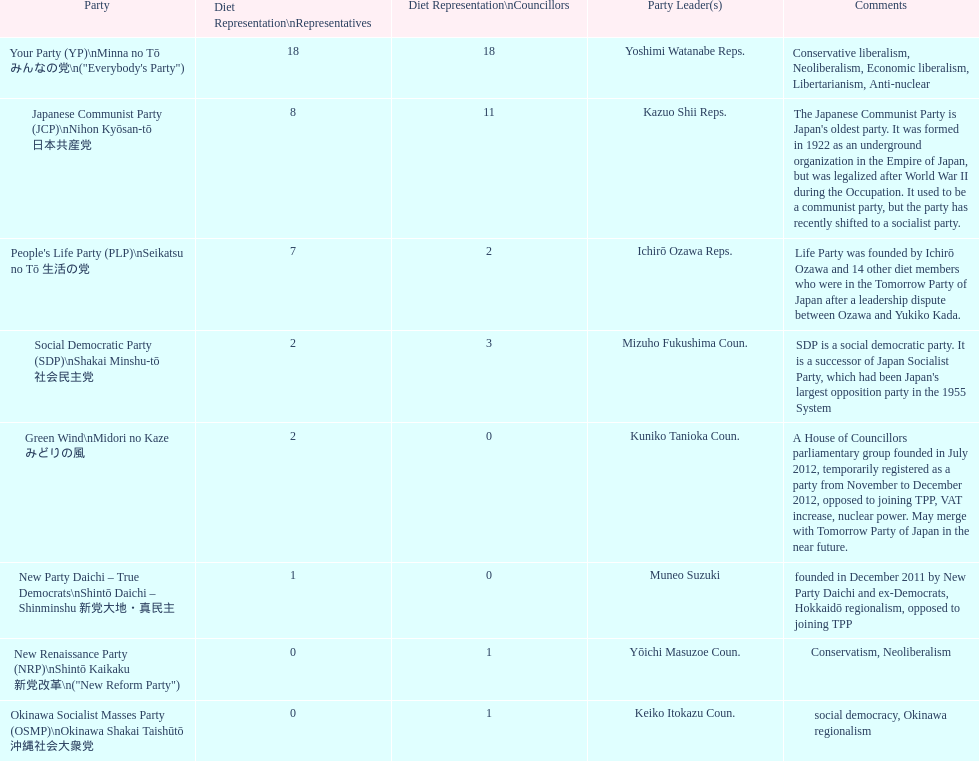What is the maximum number of party leaders in the people's life party? 1. 